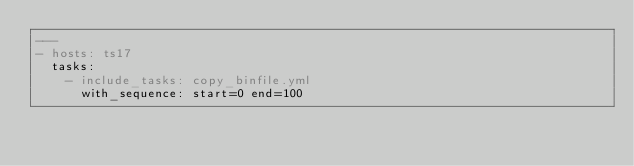<code> <loc_0><loc_0><loc_500><loc_500><_YAML_>---
- hosts: ts17
  tasks:
    - include_tasks: copy_binfile.yml
      with_sequence: start=0 end=100
</code> 